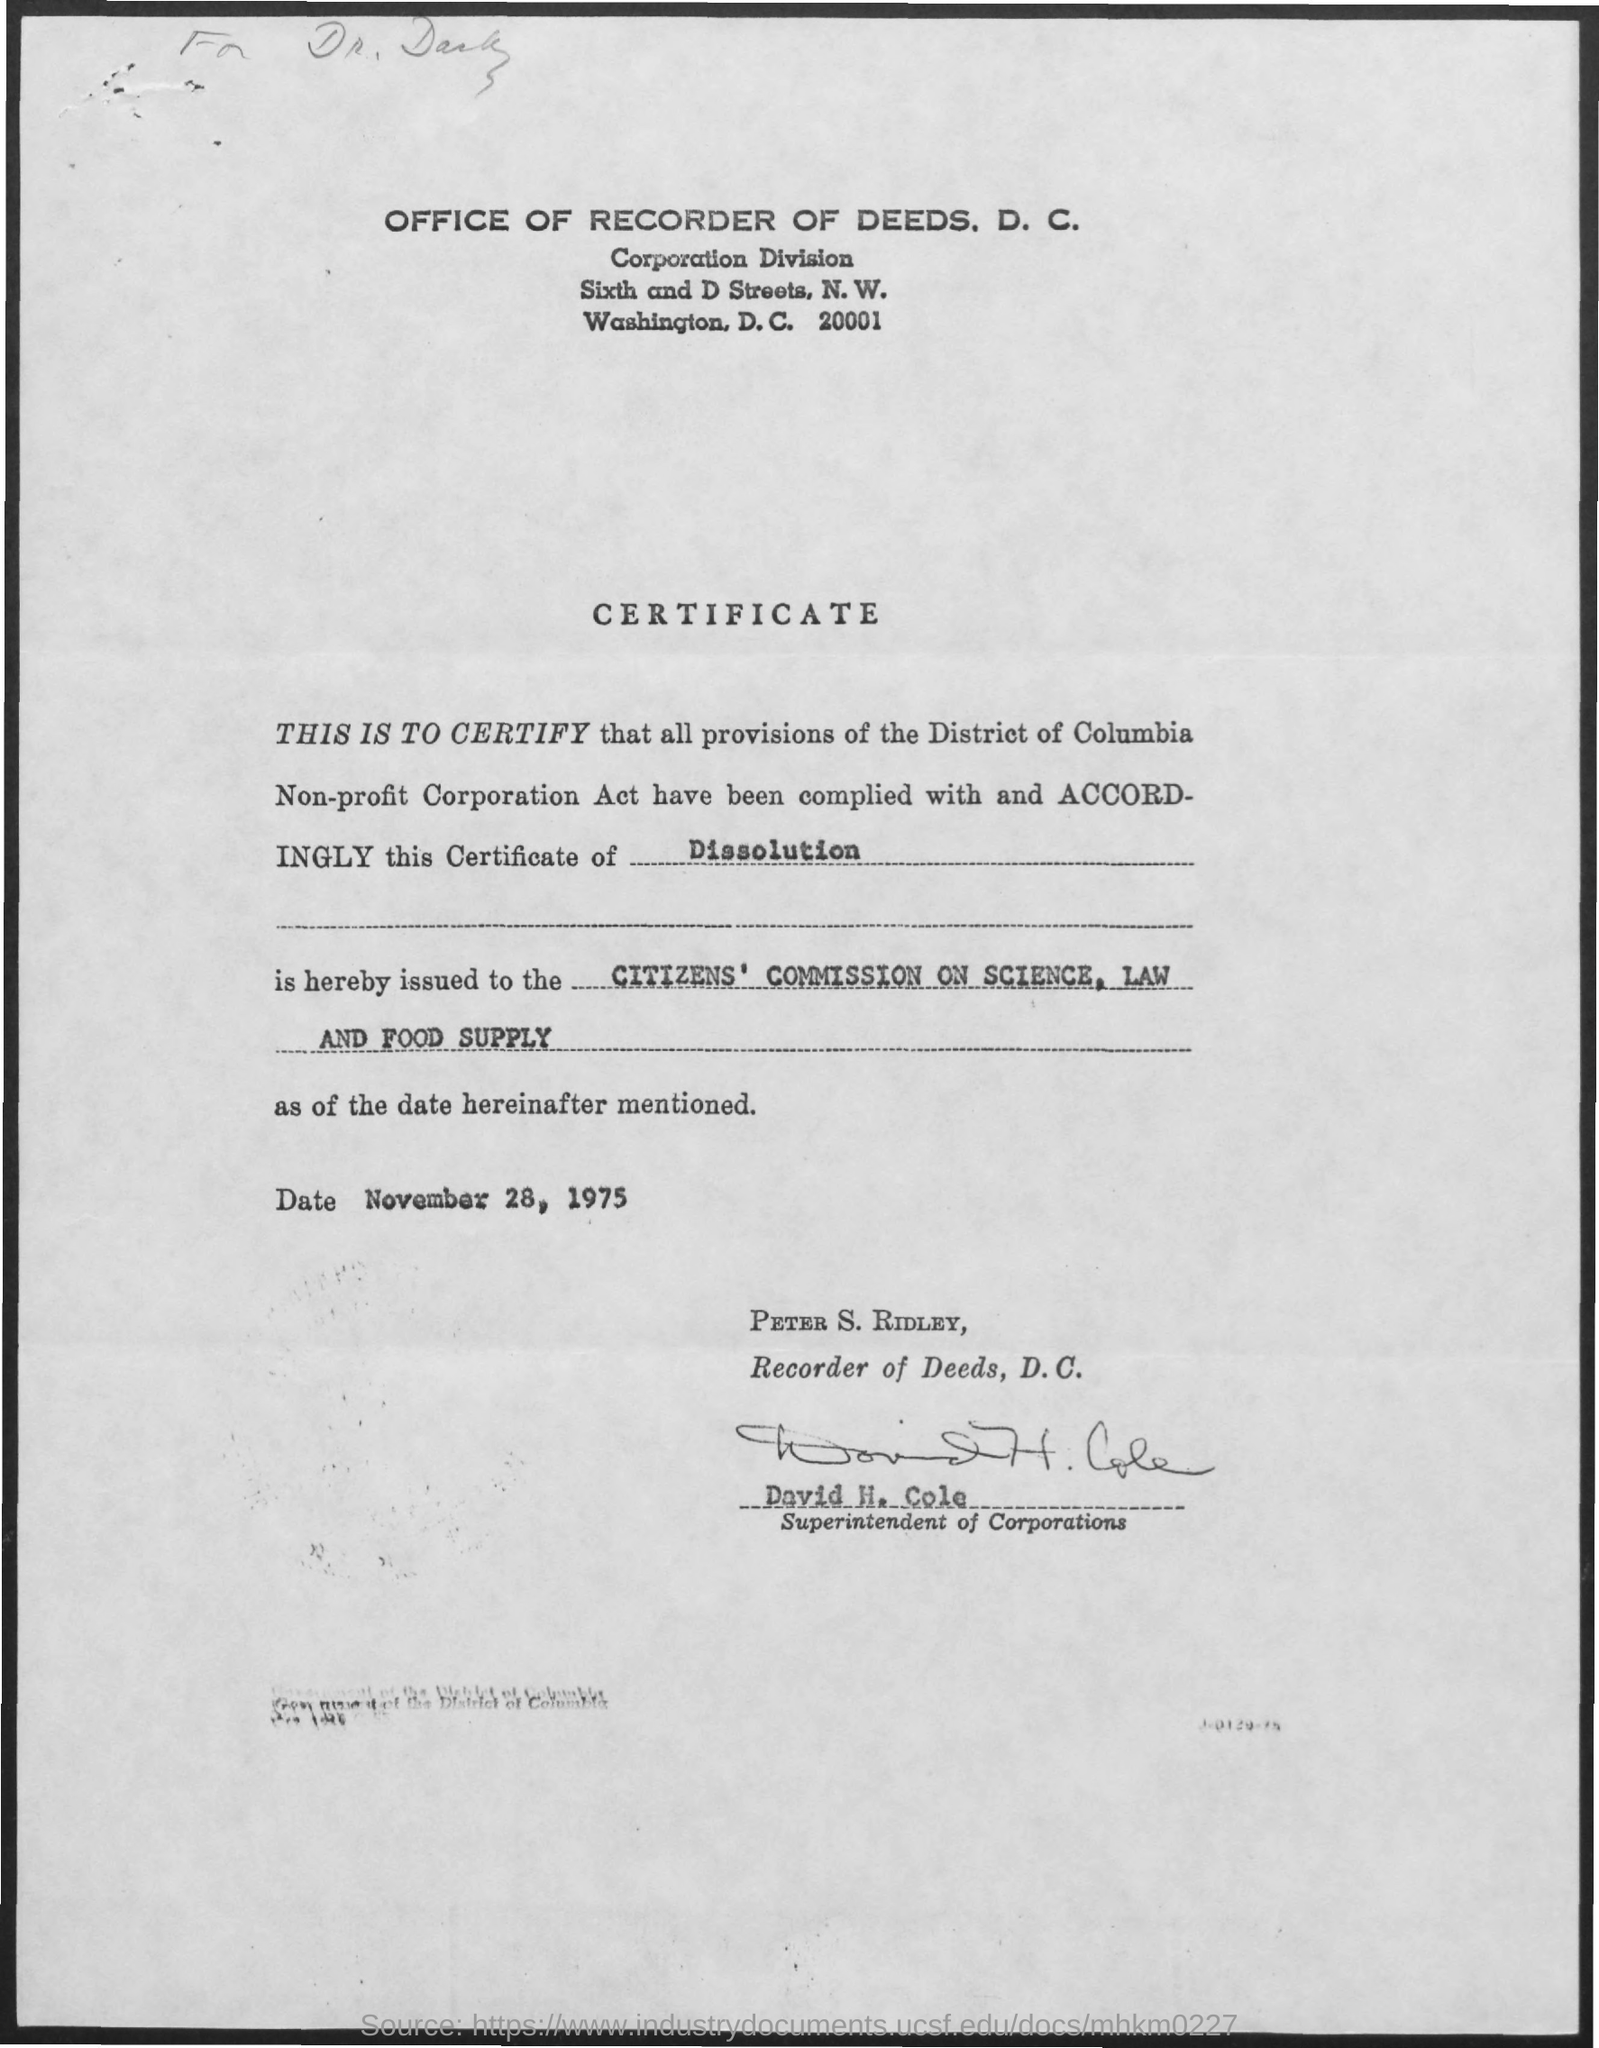Who is the superintendent of corporations ?
Provide a short and direct response. David H cole. What is the date mentioned ?
Provide a short and direct response. November 28, 1975. Who is the recorder of deeds , d.c.
Offer a very short reply. Peter S . Ridley. 